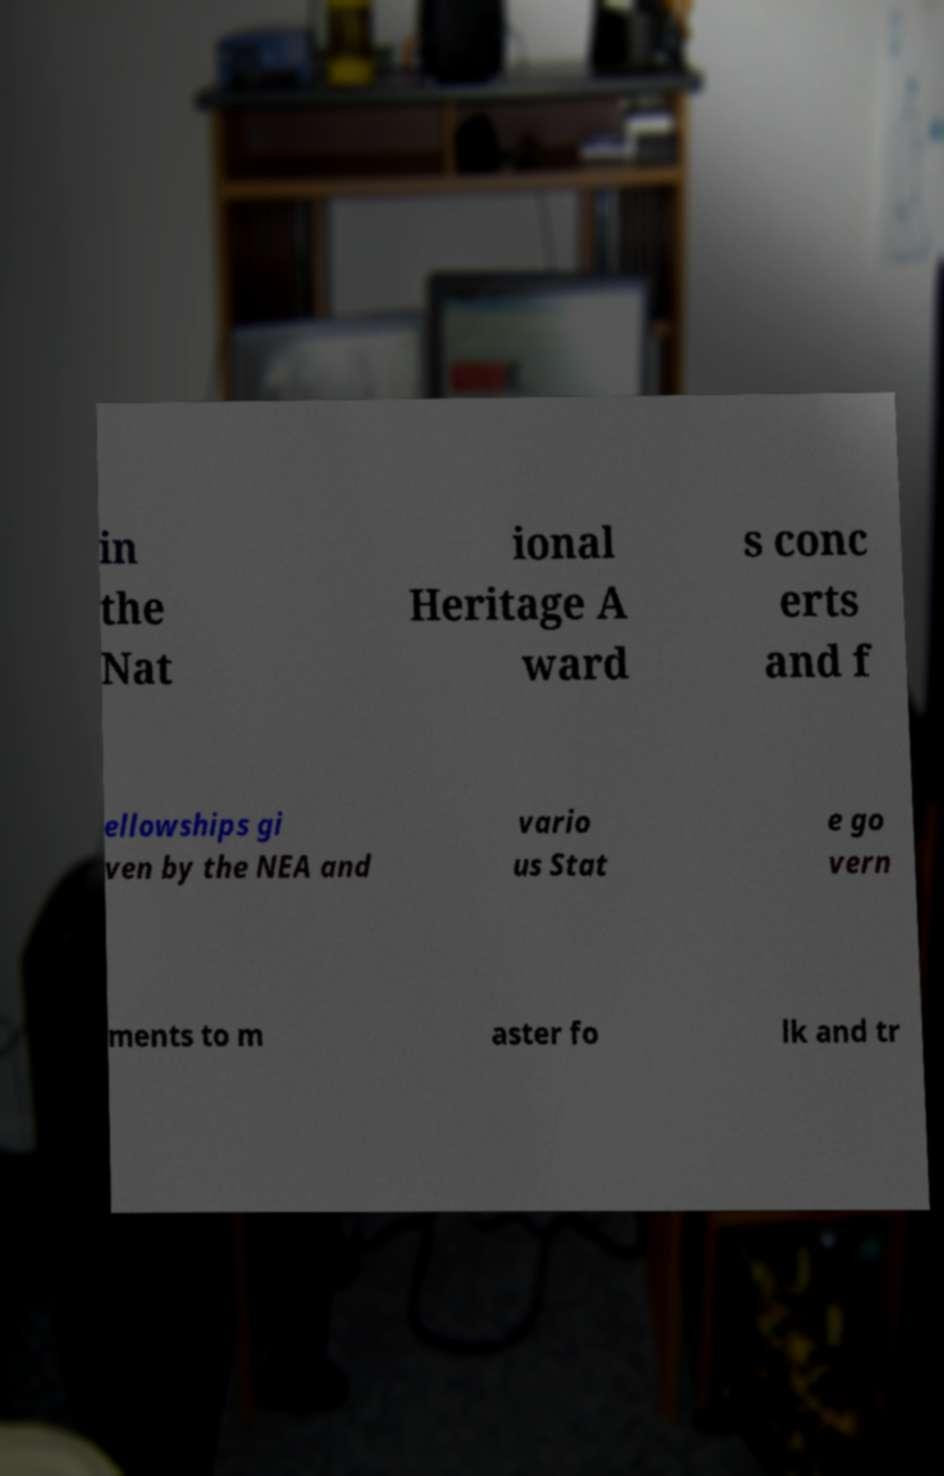Can you read and provide the text displayed in the image?This photo seems to have some interesting text. Can you extract and type it out for me? in the Nat ional Heritage A ward s conc erts and f ellowships gi ven by the NEA and vario us Stat e go vern ments to m aster fo lk and tr 